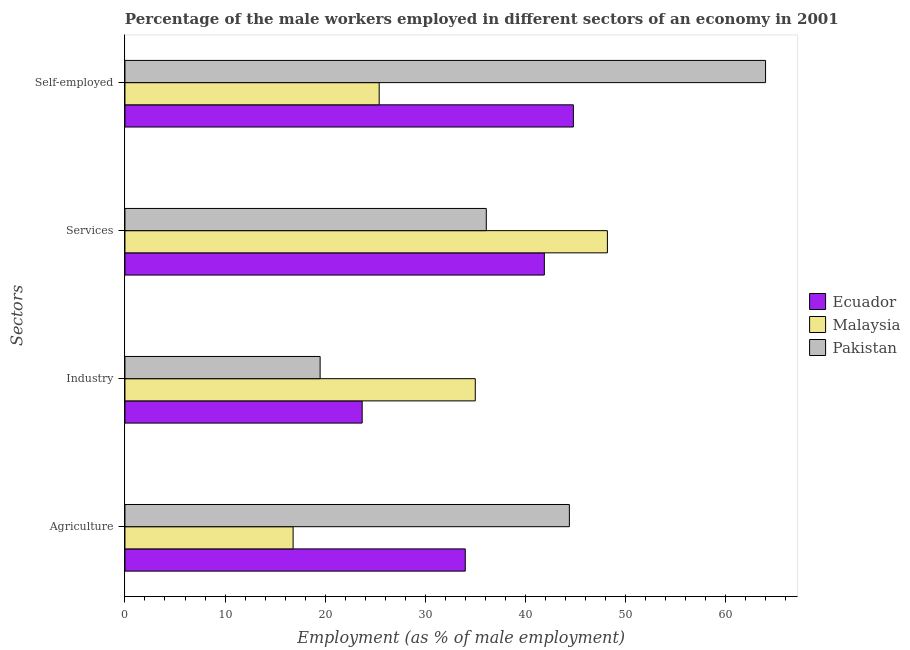How many different coloured bars are there?
Make the answer very short. 3. How many bars are there on the 3rd tick from the bottom?
Offer a very short reply. 3. What is the label of the 3rd group of bars from the top?
Offer a terse response. Industry. What is the percentage of self employed male workers in Malaysia?
Provide a succinct answer. 25.4. Across all countries, what is the minimum percentage of male workers in agriculture?
Ensure brevity in your answer.  16.8. In which country was the percentage of male workers in services maximum?
Ensure brevity in your answer.  Malaysia. What is the total percentage of male workers in industry in the graph?
Give a very brief answer. 78.2. What is the difference between the percentage of male workers in services in Pakistan and that in Ecuador?
Your answer should be compact. -5.8. What is the difference between the percentage of male workers in services in Pakistan and the percentage of male workers in industry in Malaysia?
Give a very brief answer. 1.1. What is the average percentage of self employed male workers per country?
Offer a very short reply. 44.73. What is the difference between the percentage of male workers in agriculture and percentage of self employed male workers in Ecuador?
Your response must be concise. -10.8. What is the ratio of the percentage of self employed male workers in Pakistan to that in Ecuador?
Your answer should be very brief. 1.43. Is the percentage of male workers in agriculture in Malaysia less than that in Ecuador?
Provide a short and direct response. Yes. What is the difference between the highest and the second highest percentage of male workers in services?
Offer a very short reply. 6.3. What is the difference between the highest and the lowest percentage of self employed male workers?
Your answer should be very brief. 38.6. In how many countries, is the percentage of male workers in industry greater than the average percentage of male workers in industry taken over all countries?
Your answer should be very brief. 1. Is the sum of the percentage of male workers in industry in Malaysia and Pakistan greater than the maximum percentage of male workers in agriculture across all countries?
Ensure brevity in your answer.  Yes. What does the 1st bar from the top in Self-employed represents?
Keep it short and to the point. Pakistan. What does the 2nd bar from the bottom in Industry represents?
Your answer should be very brief. Malaysia. Is it the case that in every country, the sum of the percentage of male workers in agriculture and percentage of male workers in industry is greater than the percentage of male workers in services?
Keep it short and to the point. Yes. How many countries are there in the graph?
Give a very brief answer. 3. What is the difference between two consecutive major ticks on the X-axis?
Offer a very short reply. 10. Are the values on the major ticks of X-axis written in scientific E-notation?
Make the answer very short. No. Does the graph contain any zero values?
Make the answer very short. No. Does the graph contain grids?
Make the answer very short. No. Where does the legend appear in the graph?
Your response must be concise. Center right. What is the title of the graph?
Keep it short and to the point. Percentage of the male workers employed in different sectors of an economy in 2001. What is the label or title of the X-axis?
Keep it short and to the point. Employment (as % of male employment). What is the label or title of the Y-axis?
Offer a very short reply. Sectors. What is the Employment (as % of male employment) in Malaysia in Agriculture?
Offer a very short reply. 16.8. What is the Employment (as % of male employment) of Pakistan in Agriculture?
Make the answer very short. 44.4. What is the Employment (as % of male employment) of Ecuador in Industry?
Offer a terse response. 23.7. What is the Employment (as % of male employment) in Malaysia in Industry?
Make the answer very short. 35. What is the Employment (as % of male employment) in Pakistan in Industry?
Ensure brevity in your answer.  19.5. What is the Employment (as % of male employment) of Ecuador in Services?
Your answer should be compact. 41.9. What is the Employment (as % of male employment) in Malaysia in Services?
Your answer should be compact. 48.2. What is the Employment (as % of male employment) of Pakistan in Services?
Make the answer very short. 36.1. What is the Employment (as % of male employment) of Ecuador in Self-employed?
Provide a short and direct response. 44.8. What is the Employment (as % of male employment) in Malaysia in Self-employed?
Give a very brief answer. 25.4. What is the Employment (as % of male employment) in Pakistan in Self-employed?
Offer a terse response. 64. Across all Sectors, what is the maximum Employment (as % of male employment) of Ecuador?
Your answer should be very brief. 44.8. Across all Sectors, what is the maximum Employment (as % of male employment) of Malaysia?
Keep it short and to the point. 48.2. Across all Sectors, what is the maximum Employment (as % of male employment) of Pakistan?
Give a very brief answer. 64. Across all Sectors, what is the minimum Employment (as % of male employment) in Ecuador?
Provide a succinct answer. 23.7. Across all Sectors, what is the minimum Employment (as % of male employment) of Malaysia?
Give a very brief answer. 16.8. Across all Sectors, what is the minimum Employment (as % of male employment) of Pakistan?
Give a very brief answer. 19.5. What is the total Employment (as % of male employment) of Ecuador in the graph?
Keep it short and to the point. 144.4. What is the total Employment (as % of male employment) in Malaysia in the graph?
Ensure brevity in your answer.  125.4. What is the total Employment (as % of male employment) of Pakistan in the graph?
Make the answer very short. 164. What is the difference between the Employment (as % of male employment) in Ecuador in Agriculture and that in Industry?
Provide a short and direct response. 10.3. What is the difference between the Employment (as % of male employment) of Malaysia in Agriculture and that in Industry?
Your answer should be compact. -18.2. What is the difference between the Employment (as % of male employment) of Pakistan in Agriculture and that in Industry?
Your answer should be very brief. 24.9. What is the difference between the Employment (as % of male employment) of Ecuador in Agriculture and that in Services?
Offer a very short reply. -7.9. What is the difference between the Employment (as % of male employment) of Malaysia in Agriculture and that in Services?
Offer a terse response. -31.4. What is the difference between the Employment (as % of male employment) in Malaysia in Agriculture and that in Self-employed?
Provide a succinct answer. -8.6. What is the difference between the Employment (as % of male employment) of Pakistan in Agriculture and that in Self-employed?
Keep it short and to the point. -19.6. What is the difference between the Employment (as % of male employment) of Ecuador in Industry and that in Services?
Your response must be concise. -18.2. What is the difference between the Employment (as % of male employment) in Malaysia in Industry and that in Services?
Your answer should be very brief. -13.2. What is the difference between the Employment (as % of male employment) in Pakistan in Industry and that in Services?
Provide a short and direct response. -16.6. What is the difference between the Employment (as % of male employment) of Ecuador in Industry and that in Self-employed?
Provide a succinct answer. -21.1. What is the difference between the Employment (as % of male employment) of Pakistan in Industry and that in Self-employed?
Your response must be concise. -44.5. What is the difference between the Employment (as % of male employment) of Ecuador in Services and that in Self-employed?
Your answer should be compact. -2.9. What is the difference between the Employment (as % of male employment) in Malaysia in Services and that in Self-employed?
Offer a very short reply. 22.8. What is the difference between the Employment (as % of male employment) in Pakistan in Services and that in Self-employed?
Offer a terse response. -27.9. What is the difference between the Employment (as % of male employment) of Ecuador in Agriculture and the Employment (as % of male employment) of Malaysia in Industry?
Offer a terse response. -1. What is the difference between the Employment (as % of male employment) of Ecuador in Agriculture and the Employment (as % of male employment) of Pakistan in Industry?
Provide a succinct answer. 14.5. What is the difference between the Employment (as % of male employment) of Malaysia in Agriculture and the Employment (as % of male employment) of Pakistan in Industry?
Provide a succinct answer. -2.7. What is the difference between the Employment (as % of male employment) of Ecuador in Agriculture and the Employment (as % of male employment) of Malaysia in Services?
Give a very brief answer. -14.2. What is the difference between the Employment (as % of male employment) in Malaysia in Agriculture and the Employment (as % of male employment) in Pakistan in Services?
Provide a short and direct response. -19.3. What is the difference between the Employment (as % of male employment) of Ecuador in Agriculture and the Employment (as % of male employment) of Pakistan in Self-employed?
Provide a short and direct response. -30. What is the difference between the Employment (as % of male employment) in Malaysia in Agriculture and the Employment (as % of male employment) in Pakistan in Self-employed?
Offer a terse response. -47.2. What is the difference between the Employment (as % of male employment) in Ecuador in Industry and the Employment (as % of male employment) in Malaysia in Services?
Provide a succinct answer. -24.5. What is the difference between the Employment (as % of male employment) in Ecuador in Industry and the Employment (as % of male employment) in Pakistan in Self-employed?
Keep it short and to the point. -40.3. What is the difference between the Employment (as % of male employment) in Malaysia in Industry and the Employment (as % of male employment) in Pakistan in Self-employed?
Ensure brevity in your answer.  -29. What is the difference between the Employment (as % of male employment) in Ecuador in Services and the Employment (as % of male employment) in Pakistan in Self-employed?
Offer a terse response. -22.1. What is the difference between the Employment (as % of male employment) in Malaysia in Services and the Employment (as % of male employment) in Pakistan in Self-employed?
Provide a succinct answer. -15.8. What is the average Employment (as % of male employment) of Ecuador per Sectors?
Make the answer very short. 36.1. What is the average Employment (as % of male employment) of Malaysia per Sectors?
Offer a terse response. 31.35. What is the average Employment (as % of male employment) of Pakistan per Sectors?
Your answer should be very brief. 41. What is the difference between the Employment (as % of male employment) of Malaysia and Employment (as % of male employment) of Pakistan in Agriculture?
Your response must be concise. -27.6. What is the difference between the Employment (as % of male employment) of Malaysia and Employment (as % of male employment) of Pakistan in Industry?
Make the answer very short. 15.5. What is the difference between the Employment (as % of male employment) in Ecuador and Employment (as % of male employment) in Malaysia in Services?
Offer a terse response. -6.3. What is the difference between the Employment (as % of male employment) of Ecuador and Employment (as % of male employment) of Pakistan in Services?
Your answer should be very brief. 5.8. What is the difference between the Employment (as % of male employment) of Ecuador and Employment (as % of male employment) of Malaysia in Self-employed?
Offer a very short reply. 19.4. What is the difference between the Employment (as % of male employment) of Ecuador and Employment (as % of male employment) of Pakistan in Self-employed?
Give a very brief answer. -19.2. What is the difference between the Employment (as % of male employment) in Malaysia and Employment (as % of male employment) in Pakistan in Self-employed?
Make the answer very short. -38.6. What is the ratio of the Employment (as % of male employment) in Ecuador in Agriculture to that in Industry?
Your answer should be compact. 1.43. What is the ratio of the Employment (as % of male employment) in Malaysia in Agriculture to that in Industry?
Offer a terse response. 0.48. What is the ratio of the Employment (as % of male employment) in Pakistan in Agriculture to that in Industry?
Offer a very short reply. 2.28. What is the ratio of the Employment (as % of male employment) of Ecuador in Agriculture to that in Services?
Ensure brevity in your answer.  0.81. What is the ratio of the Employment (as % of male employment) in Malaysia in Agriculture to that in Services?
Provide a short and direct response. 0.35. What is the ratio of the Employment (as % of male employment) in Pakistan in Agriculture to that in Services?
Your answer should be compact. 1.23. What is the ratio of the Employment (as % of male employment) in Ecuador in Agriculture to that in Self-employed?
Provide a succinct answer. 0.76. What is the ratio of the Employment (as % of male employment) in Malaysia in Agriculture to that in Self-employed?
Your answer should be compact. 0.66. What is the ratio of the Employment (as % of male employment) in Pakistan in Agriculture to that in Self-employed?
Your answer should be very brief. 0.69. What is the ratio of the Employment (as % of male employment) in Ecuador in Industry to that in Services?
Your answer should be very brief. 0.57. What is the ratio of the Employment (as % of male employment) of Malaysia in Industry to that in Services?
Keep it short and to the point. 0.73. What is the ratio of the Employment (as % of male employment) in Pakistan in Industry to that in Services?
Your answer should be very brief. 0.54. What is the ratio of the Employment (as % of male employment) in Ecuador in Industry to that in Self-employed?
Provide a short and direct response. 0.53. What is the ratio of the Employment (as % of male employment) in Malaysia in Industry to that in Self-employed?
Your response must be concise. 1.38. What is the ratio of the Employment (as % of male employment) of Pakistan in Industry to that in Self-employed?
Your response must be concise. 0.3. What is the ratio of the Employment (as % of male employment) of Ecuador in Services to that in Self-employed?
Offer a terse response. 0.94. What is the ratio of the Employment (as % of male employment) in Malaysia in Services to that in Self-employed?
Ensure brevity in your answer.  1.9. What is the ratio of the Employment (as % of male employment) in Pakistan in Services to that in Self-employed?
Make the answer very short. 0.56. What is the difference between the highest and the second highest Employment (as % of male employment) in Malaysia?
Your answer should be compact. 13.2. What is the difference between the highest and the second highest Employment (as % of male employment) of Pakistan?
Provide a short and direct response. 19.6. What is the difference between the highest and the lowest Employment (as % of male employment) in Ecuador?
Your answer should be very brief. 21.1. What is the difference between the highest and the lowest Employment (as % of male employment) in Malaysia?
Give a very brief answer. 31.4. What is the difference between the highest and the lowest Employment (as % of male employment) in Pakistan?
Your answer should be compact. 44.5. 